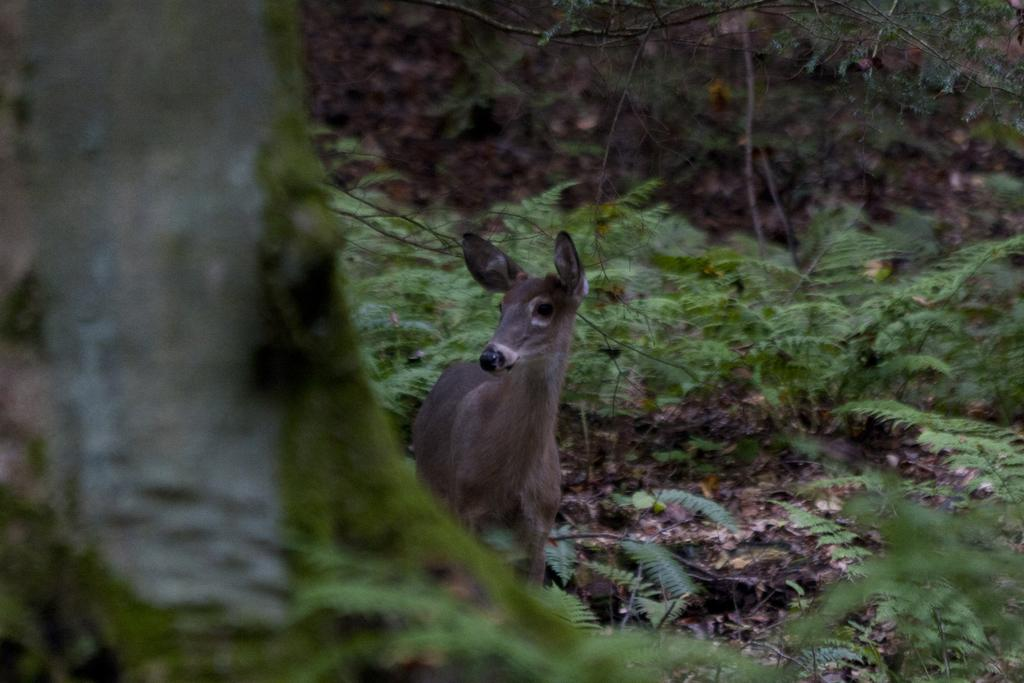What type of animal can be seen in the picture? There is a deer in the picture. What natural elements are present in the picture? There are trees and plants in the picture. What type of cup can be seen in the picture? There is no cup present in the picture; it features a deer, trees, and plants. How many flocks of birds are visible in the picture? There are no birds or flocks present in the picture. 